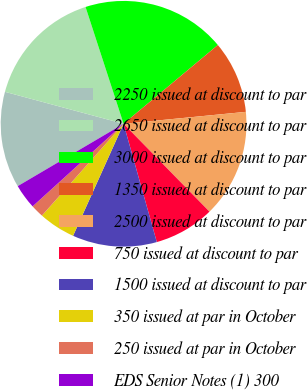Convert chart. <chart><loc_0><loc_0><loc_500><loc_500><pie_chart><fcel>2250 issued at discount to par<fcel>2650 issued at discount to par<fcel>3000 issued at discount to par<fcel>1350 issued at discount to par<fcel>2500 issued at discount to par<fcel>750 issued at discount to par<fcel>1500 issued at discount to par<fcel>350 issued at par in October<fcel>250 issued at par in October<fcel>EDS Senior Notes (1) 300<nl><fcel>12.66%<fcel>15.8%<fcel>18.93%<fcel>9.53%<fcel>14.23%<fcel>7.96%<fcel>11.1%<fcel>4.83%<fcel>1.7%<fcel>3.26%<nl></chart> 